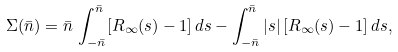<formula> <loc_0><loc_0><loc_500><loc_500>\Sigma ( \bar { n } ) = \bar { n } \, \int _ { - \bar { n } } ^ { \bar { n } } [ R _ { \infty } ( s ) - 1 ] \, d s - \int _ { - \bar { n } } ^ { \bar { n } } | s | \, [ R _ { \infty } ( s ) - 1 ] \, d s ,</formula> 